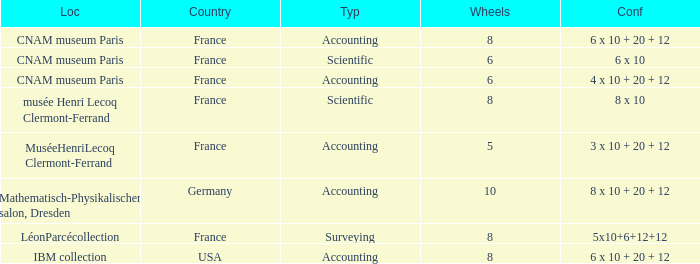What is the configuration for the country France, with accounting as the type, and wheels greater than 6? 6 x 10 + 20 + 12. 